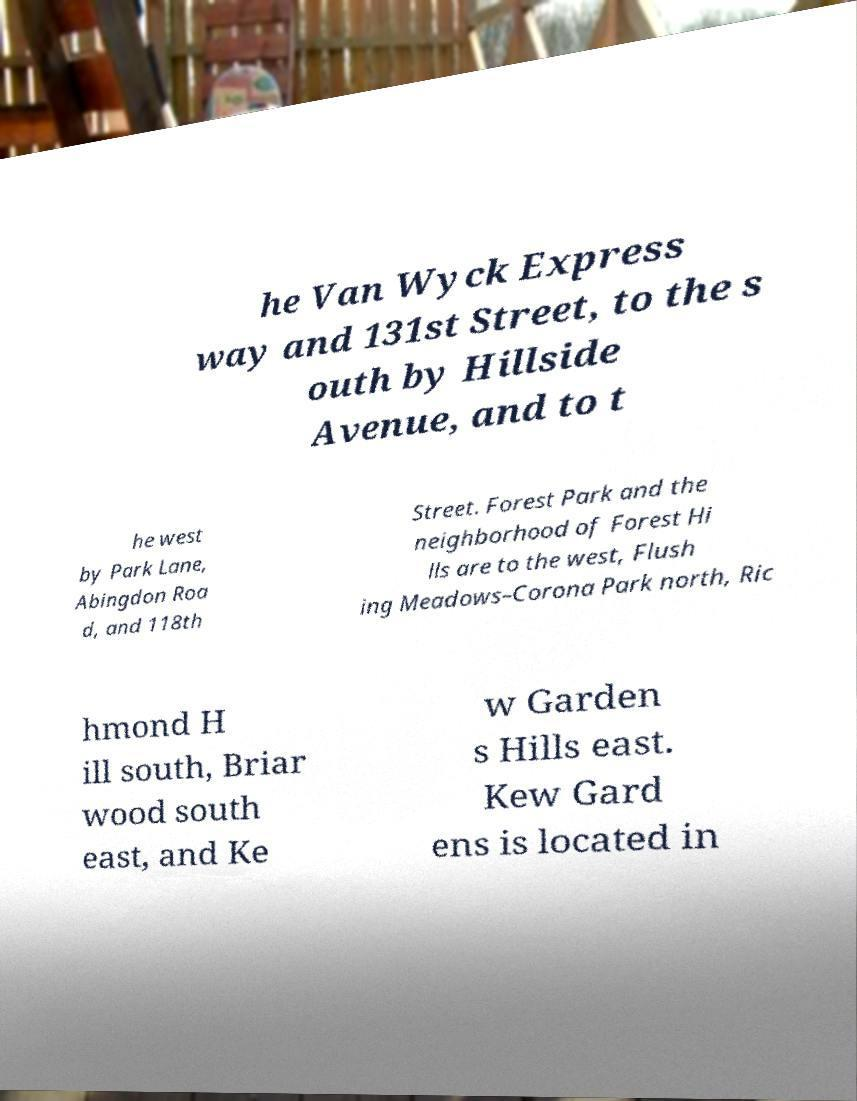Can you read and provide the text displayed in the image?This photo seems to have some interesting text. Can you extract and type it out for me? he Van Wyck Express way and 131st Street, to the s outh by Hillside Avenue, and to t he west by Park Lane, Abingdon Roa d, and 118th Street. Forest Park and the neighborhood of Forest Hi lls are to the west, Flush ing Meadows–Corona Park north, Ric hmond H ill south, Briar wood south east, and Ke w Garden s Hills east. Kew Gard ens is located in 